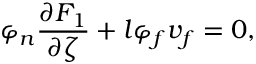<formula> <loc_0><loc_0><loc_500><loc_500>\varphi _ { n } \frac { \partial F _ { 1 } } { \partial \zeta } + l \varphi _ { f } v _ { f } = 0 ,</formula> 